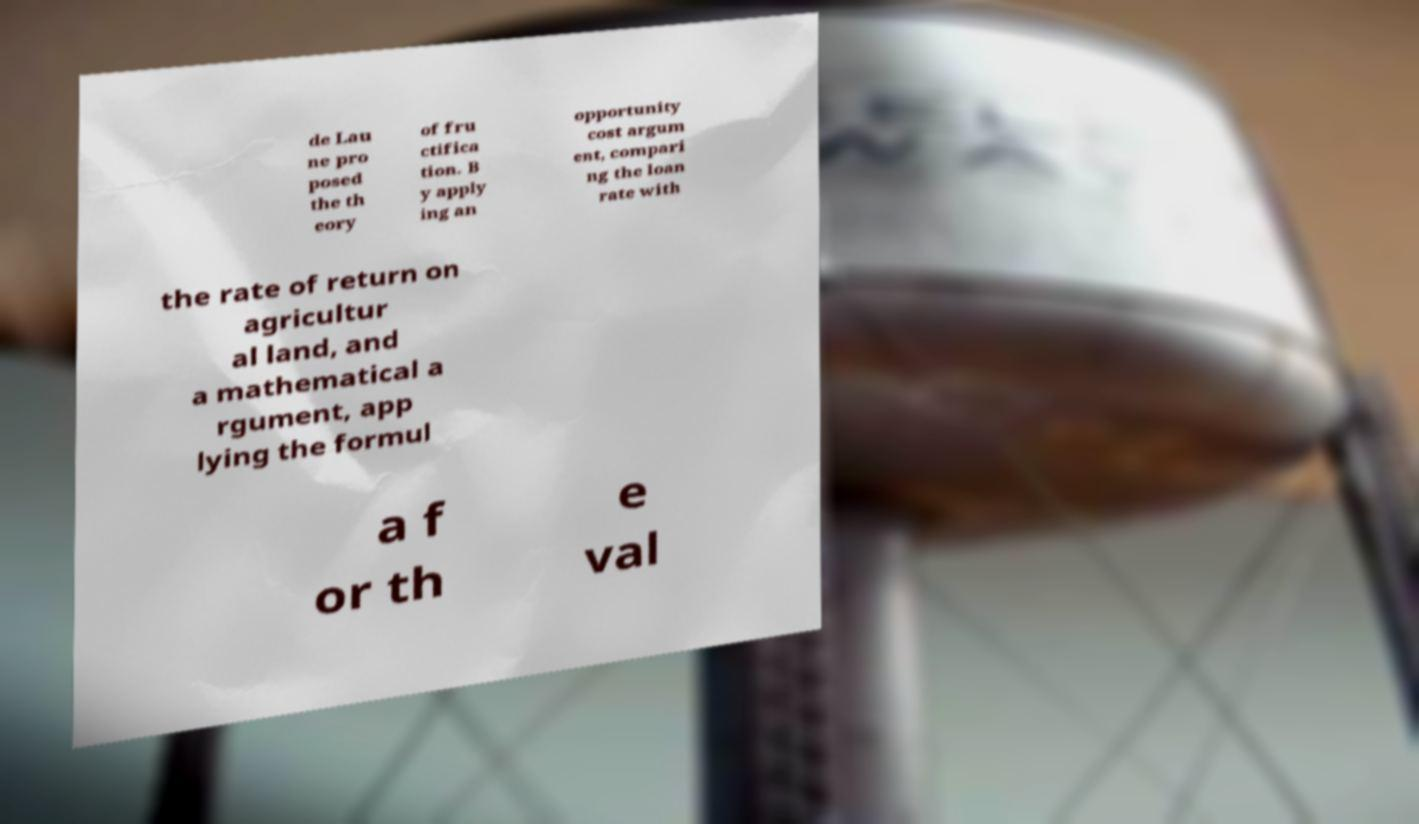Please read and relay the text visible in this image. What does it say? de Lau ne pro posed the th eory of fru ctifica tion. B y apply ing an opportunity cost argum ent, compari ng the loan rate with the rate of return on agricultur al land, and a mathematical a rgument, app lying the formul a f or th e val 